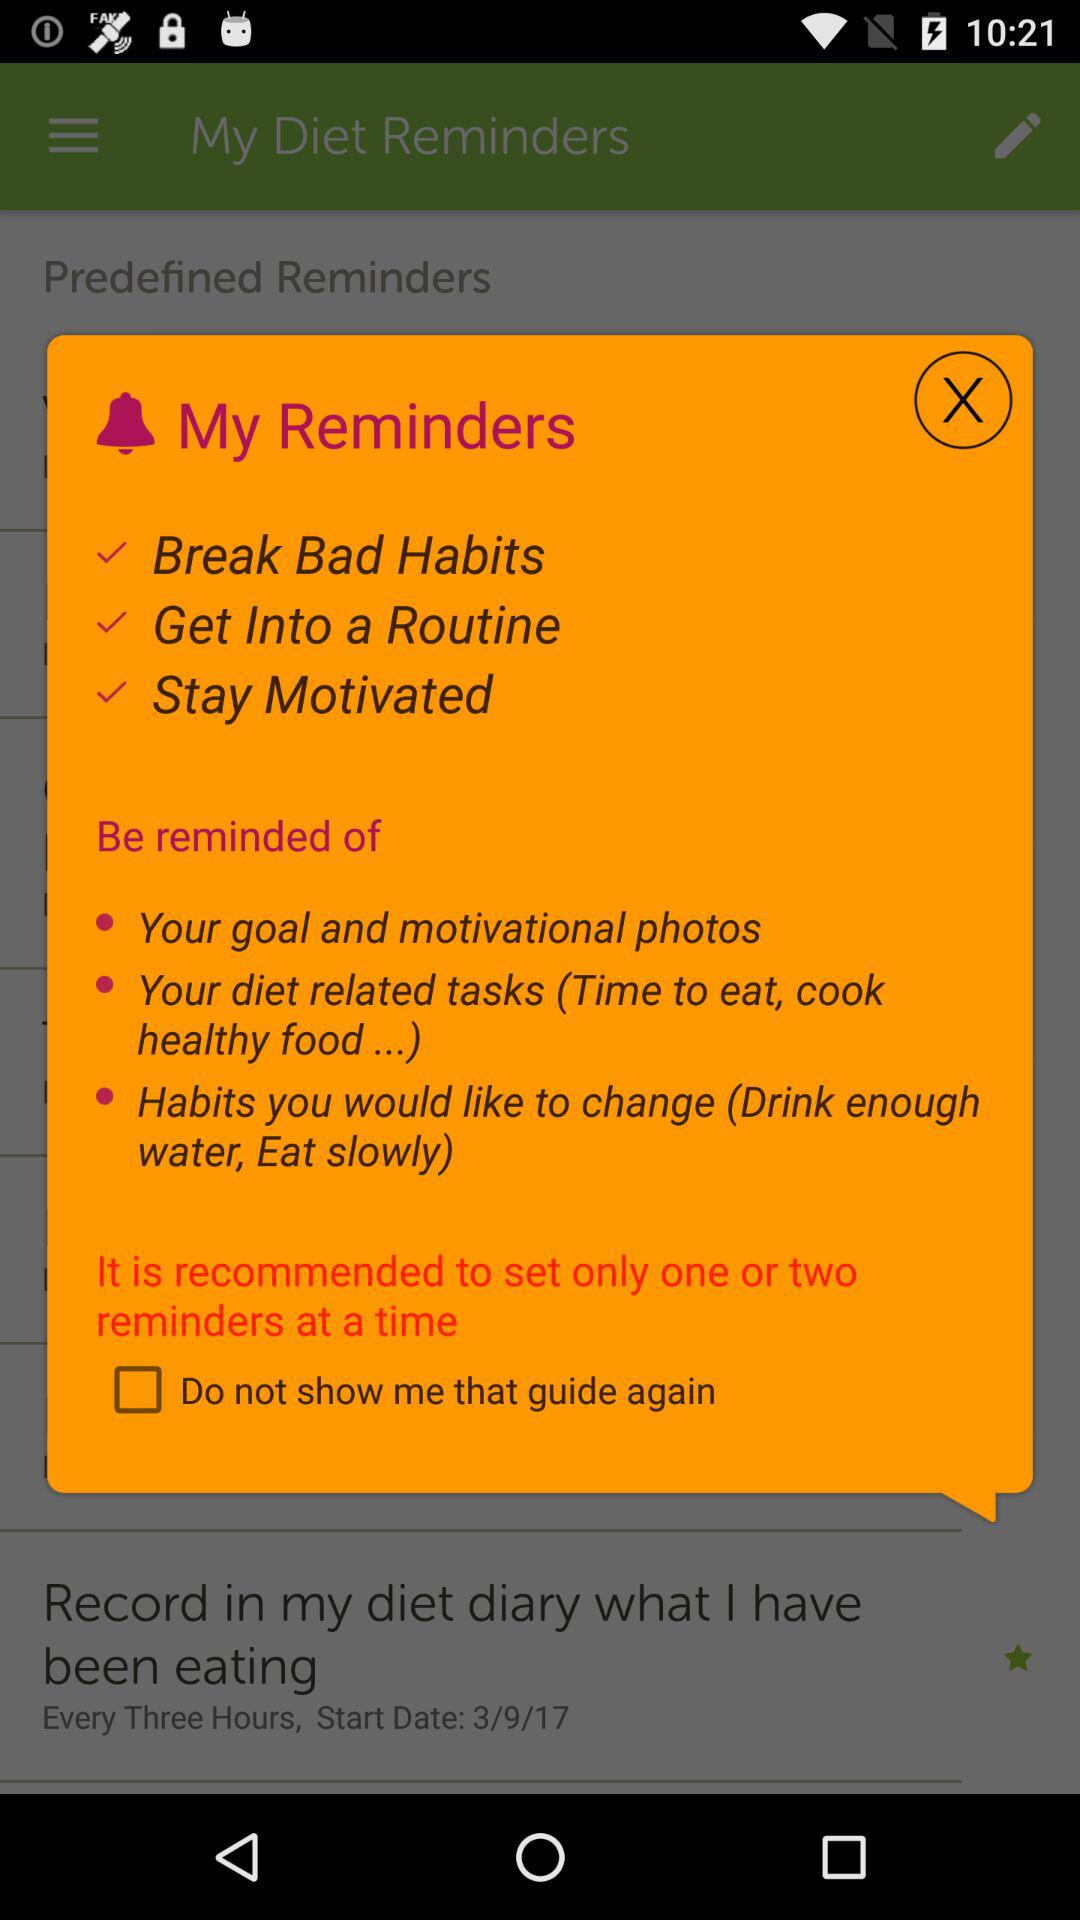What are the reminders? The reminders are to break bad habits, get into a routine and stay motivated. 